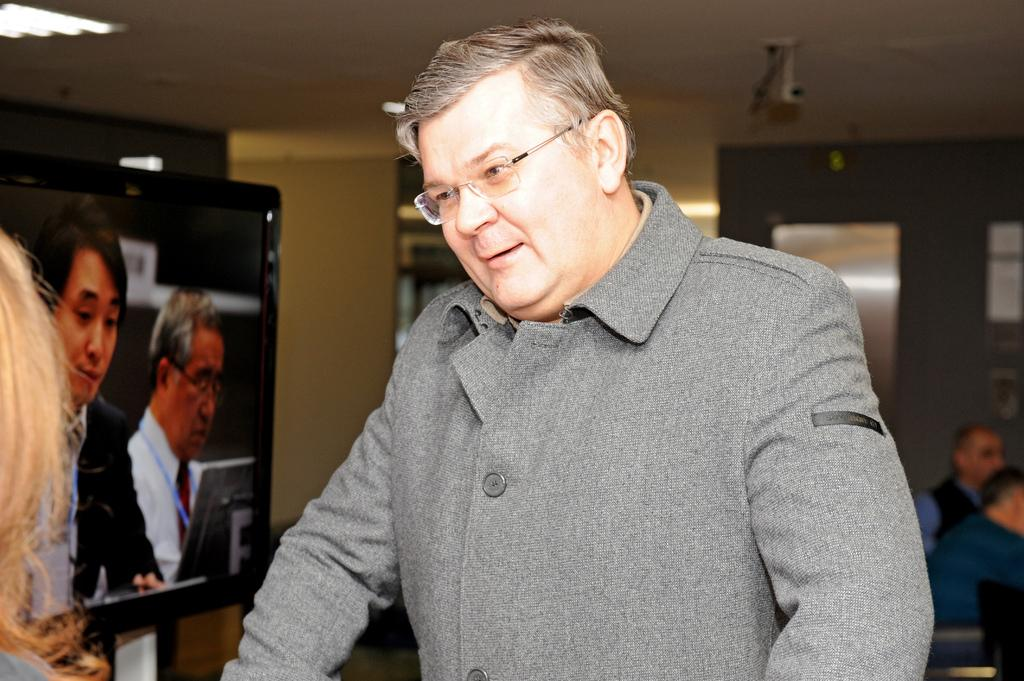What is the main subject of the image? There is a man standing in the image. What can be seen behind the man? There is a television behind the man. Are there any other people in the image? Yes, there are other people visible in the image. Where are the people located in relation to the wall? The people are beside a wall. What type of plane is being tested in the image? There is no plane present in the image; it features a man standing with a television behind him and other people beside a wall. Where is the store located in the image? There is no store present in the image. 